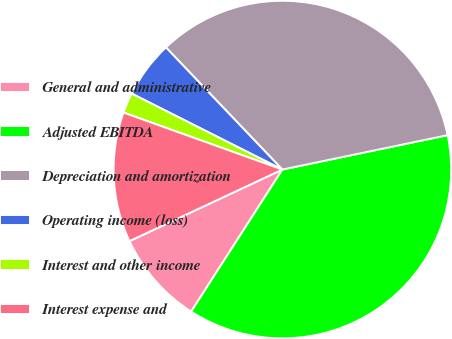<chart> <loc_0><loc_0><loc_500><loc_500><pie_chart><fcel>General and administrative<fcel>Adjusted EBITDA<fcel>Depreciation and amortization<fcel>Operating income (loss)<fcel>Interest and other income<fcel>Interest expense and<nl><fcel>8.95%<fcel>37.36%<fcel>33.86%<fcel>5.45%<fcel>1.95%<fcel>12.45%<nl></chart> 